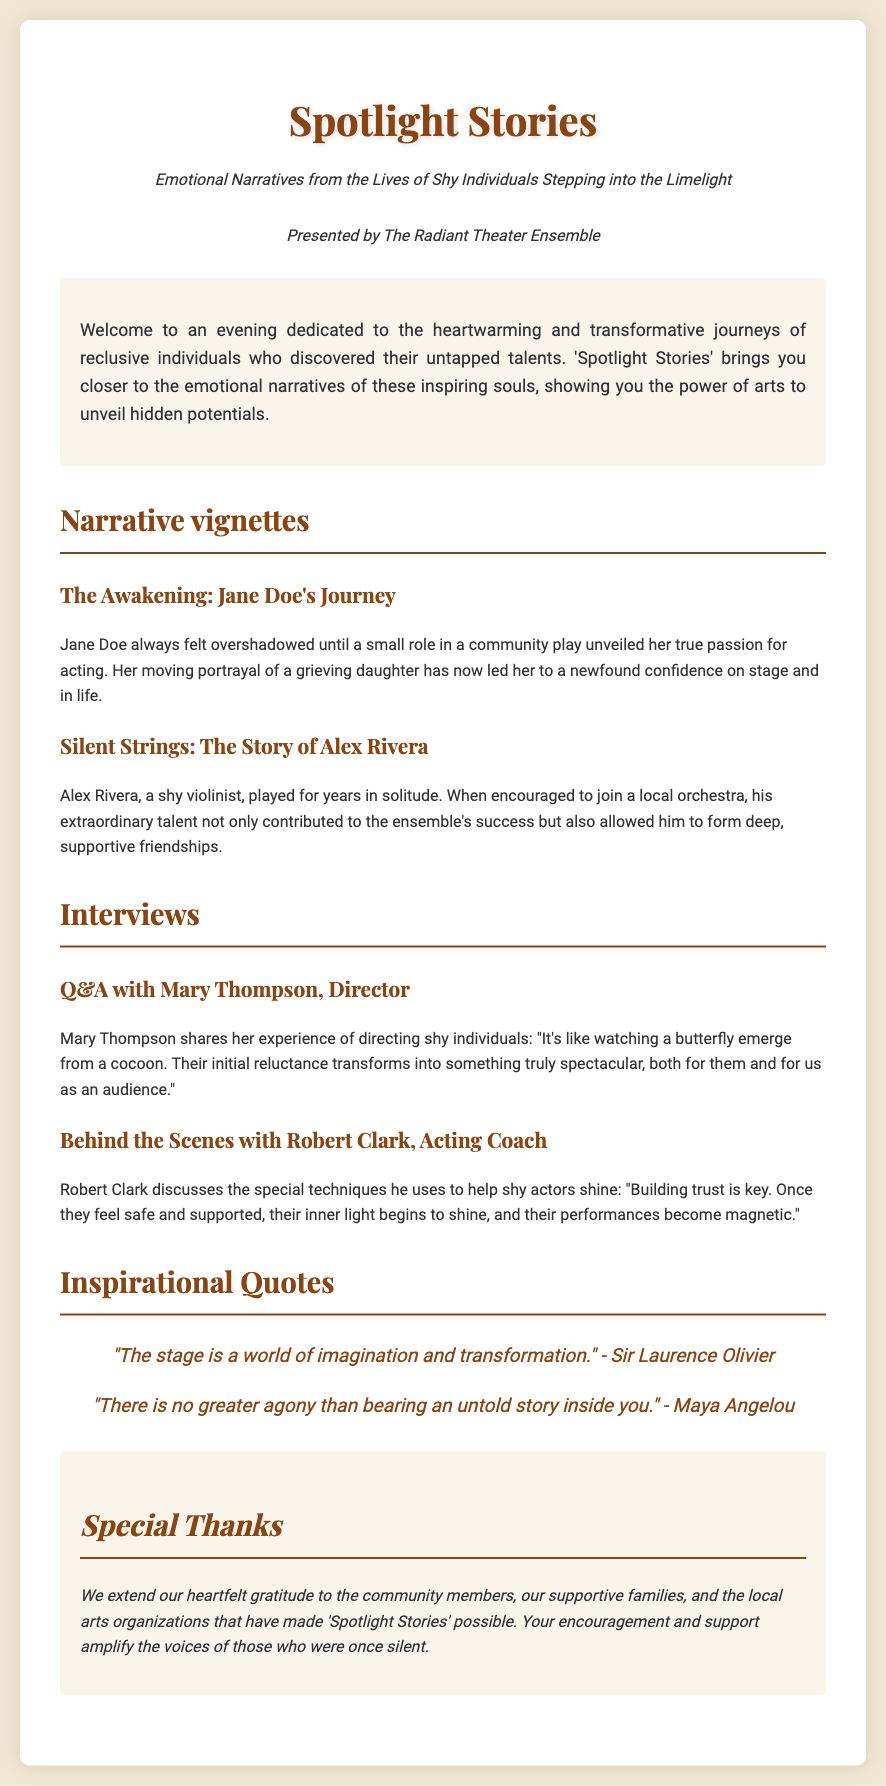What is the title of the play? The title of the play is prominently displayed at the top of the document.
Answer: Spotlight Stories Who is presenting the play? The presenting organization is mentioned in the subtitle section.
Answer: The Radiant Theater Ensemble What is the name of the first narrative vignette? The name of the first narrative vignette is listed under the "Narrative vignettes" section.
Answer: The Awakening: Jane Doe's Journey Who shares insights in the Q&A section? The document names individuals providing insights in the "Interviews" section, indicating their roles.
Answer: Mary Thompson, Director What is a key theme expressed in the inspirational quotes? The quotes suggest themes evident in the narratives and overall purpose of the performance.
Answer: Imagination and transformation How does Robert Clark describe his approach to helping shy actors? Insights are provided on techniques used to support shy actors in the "Behind the Scenes" section.
Answer: Building trust What effect does participation in the performance have according to the director? The director highlights a transformation experienced by shy individuals.
Answer: Spectacular What color is used for the background of the Playbill? The background color is mentioned as part of the style and design of the document.
Answer: #f0e6d2 